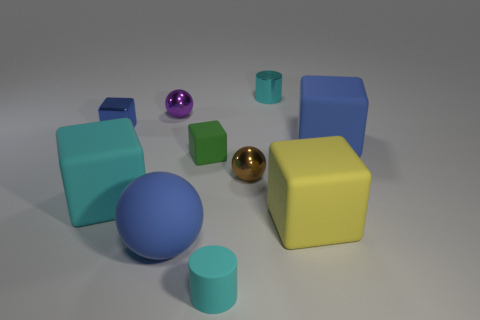Subtract all tiny spheres. How many spheres are left? 1 Subtract all cyan cubes. How many cubes are left? 4 Subtract all purple cubes. Subtract all blue balls. How many cubes are left? 5 Subtract all balls. How many objects are left? 7 Add 7 blue rubber blocks. How many blue rubber blocks are left? 8 Add 9 tiny purple metallic things. How many tiny purple metallic things exist? 10 Subtract 0 gray cylinders. How many objects are left? 10 Subtract all brown cylinders. Subtract all large blocks. How many objects are left? 7 